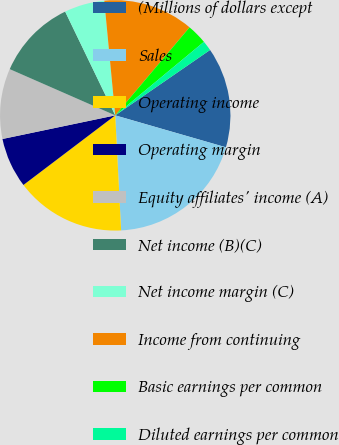Convert chart to OTSL. <chart><loc_0><loc_0><loc_500><loc_500><pie_chart><fcel>(Millions of dollars except<fcel>Sales<fcel>Operating income<fcel>Operating margin<fcel>Equity affiliates' income (A)<fcel>Net income (B)(C)<fcel>Net income margin (C)<fcel>Income from continuing<fcel>Basic earnings per common<fcel>Diluted earnings per common<nl><fcel>14.08%<fcel>19.72%<fcel>15.49%<fcel>7.04%<fcel>9.86%<fcel>11.27%<fcel>5.64%<fcel>12.68%<fcel>2.82%<fcel>1.41%<nl></chart> 